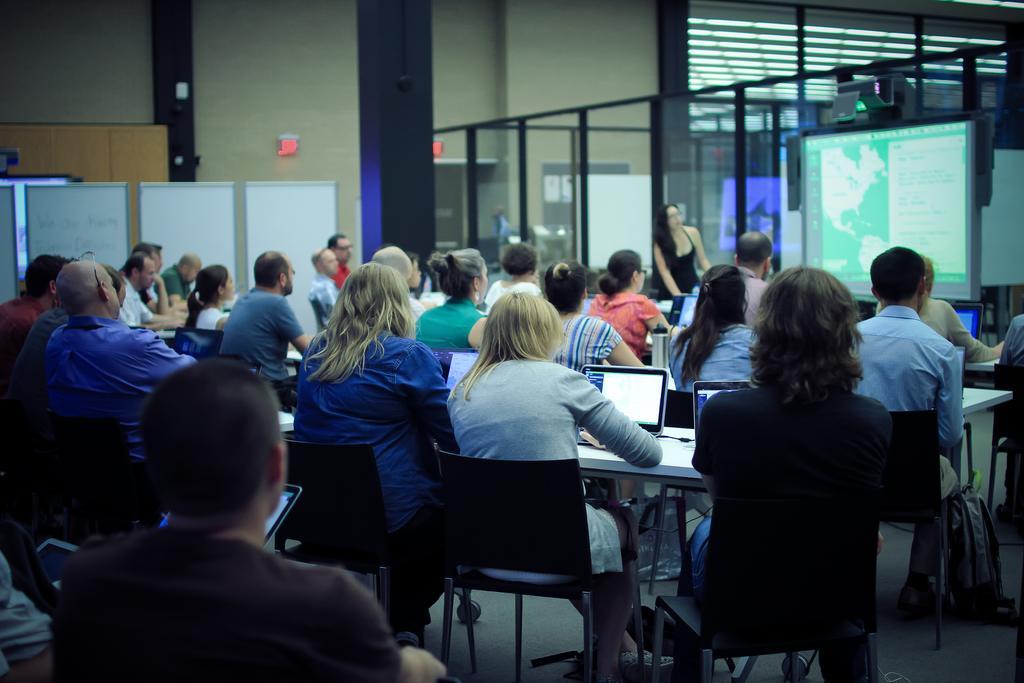Describe this image in one or two sentences. In this image we can see people sitting on the chairs near table where laptops are placed. In the background we can see a projector, glass doors and exit board on wall. 